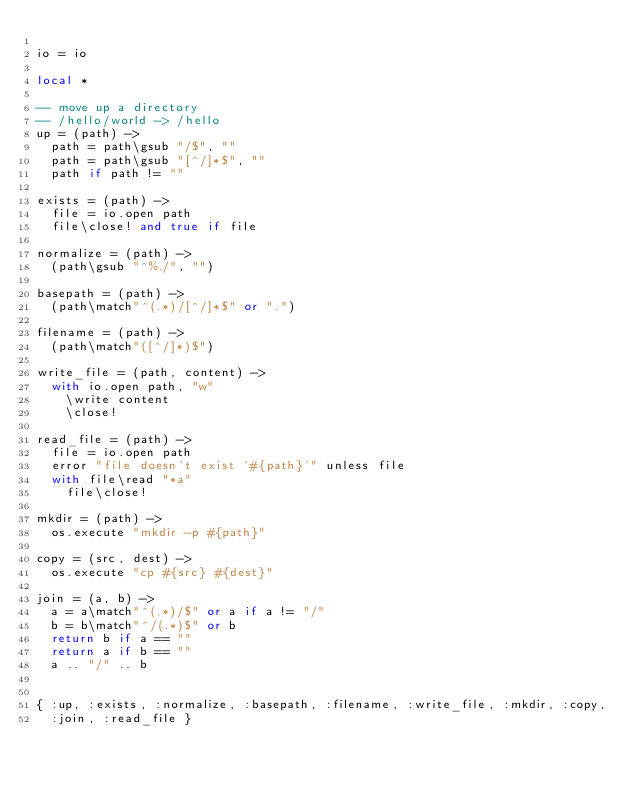<code> <loc_0><loc_0><loc_500><loc_500><_MoonScript_>
io = io

local *

-- move up a directory
-- /hello/world -> /hello
up = (path) ->
  path = path\gsub "/$", ""
  path = path\gsub "[^/]*$", ""
  path if path != ""

exists = (path) ->
  file = io.open path
  file\close! and true if file

normalize = (path) ->
  (path\gsub "^%./", "")

basepath = (path) ->
  (path\match"^(.*)/[^/]*$" or ".")

filename = (path) ->
  (path\match"([^/]*)$")

write_file = (path, content) ->
  with io.open path, "w"
    \write content
    \close!

read_file = (path) ->
  file = io.open path
  error "file doesn't exist `#{path}'" unless file
  with file\read "*a"
    file\close!

mkdir = (path) ->
  os.execute "mkdir -p #{path}"

copy = (src, dest) ->
  os.execute "cp #{src} #{dest}"

join = (a, b) ->
  a = a\match"^(.*)/$" or a if a != "/"
  b = b\match"^/(.*)$" or b
  return b if a == ""
  return a if b == ""
  a .. "/" .. b


{ :up, :exists, :normalize, :basepath, :filename, :write_file, :mkdir, :copy,
  :join, :read_file }
</code> 